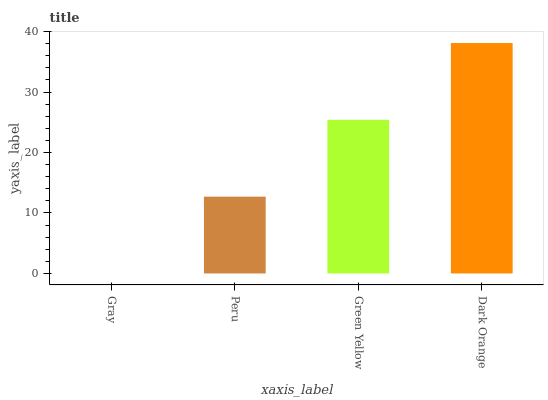Is Gray the minimum?
Answer yes or no. Yes. Is Dark Orange the maximum?
Answer yes or no. Yes. Is Peru the minimum?
Answer yes or no. No. Is Peru the maximum?
Answer yes or no. No. Is Peru greater than Gray?
Answer yes or no. Yes. Is Gray less than Peru?
Answer yes or no. Yes. Is Gray greater than Peru?
Answer yes or no. No. Is Peru less than Gray?
Answer yes or no. No. Is Green Yellow the high median?
Answer yes or no. Yes. Is Peru the low median?
Answer yes or no. Yes. Is Peru the high median?
Answer yes or no. No. Is Green Yellow the low median?
Answer yes or no. No. 